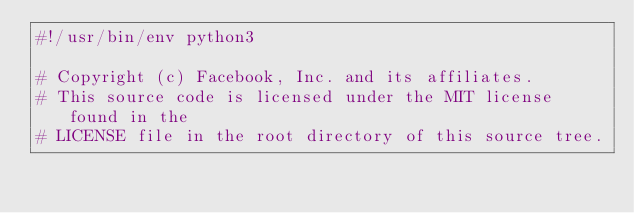<code> <loc_0><loc_0><loc_500><loc_500><_Python_>#!/usr/bin/env python3

# Copyright (c) Facebook, Inc. and its affiliates.
# This source code is licensed under the MIT license found in the
# LICENSE file in the root directory of this source tree.</code> 